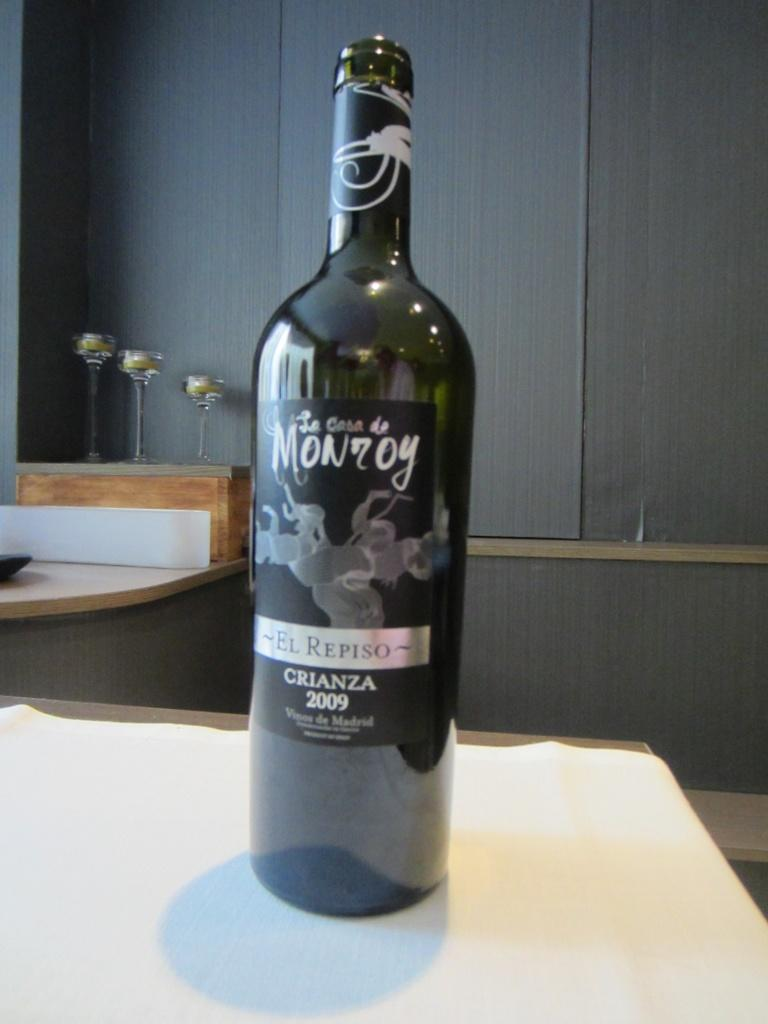Provide a one-sentence caption for the provided image. On a table sits a bottle of El Repiso Crianza 2009. 